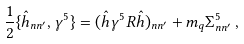Convert formula to latex. <formula><loc_0><loc_0><loc_500><loc_500>\frac { 1 } { 2 } \{ { \hat { h } } _ { n n ^ { \prime } } , \gamma ^ { 5 } \} = ( { \hat { h } } \gamma ^ { 5 } R { \hat { h } } ) _ { n n ^ { \prime } } + m _ { q } \Sigma ^ { 5 } _ { n n ^ { \prime } } \, ,</formula> 